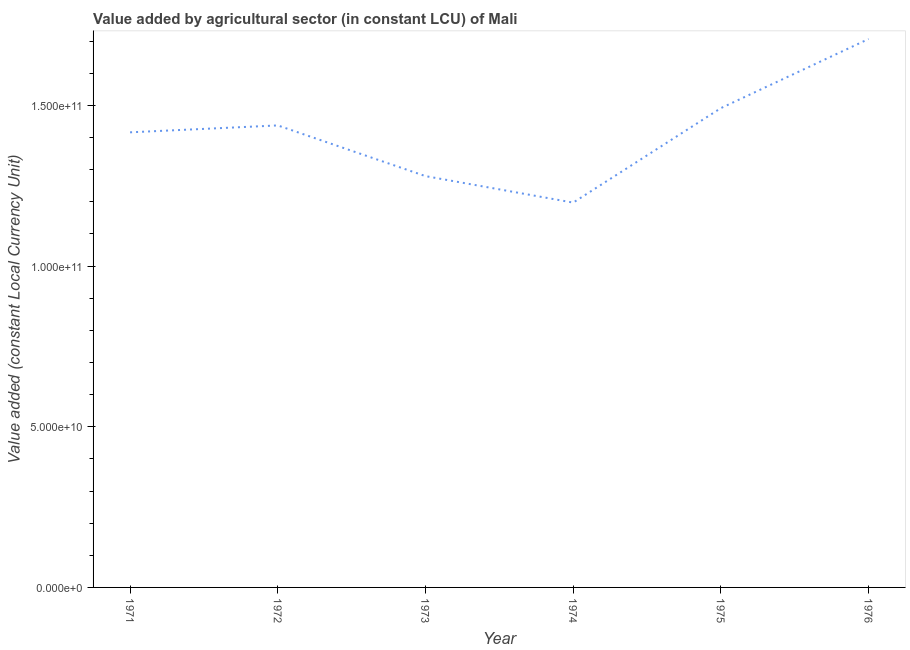What is the value added by agriculture sector in 1975?
Provide a short and direct response. 1.49e+11. Across all years, what is the maximum value added by agriculture sector?
Ensure brevity in your answer.  1.71e+11. Across all years, what is the minimum value added by agriculture sector?
Ensure brevity in your answer.  1.20e+11. In which year was the value added by agriculture sector maximum?
Ensure brevity in your answer.  1976. In which year was the value added by agriculture sector minimum?
Your answer should be compact. 1974. What is the sum of the value added by agriculture sector?
Offer a very short reply. 8.53e+11. What is the difference between the value added by agriculture sector in 1973 and 1975?
Your response must be concise. -2.12e+1. What is the average value added by agriculture sector per year?
Keep it short and to the point. 1.42e+11. What is the median value added by agriculture sector?
Your answer should be very brief. 1.43e+11. Do a majority of the years between 1971 and 1973 (inclusive) have value added by agriculture sector greater than 50000000000 LCU?
Keep it short and to the point. Yes. What is the ratio of the value added by agriculture sector in 1972 to that in 1976?
Offer a very short reply. 0.84. What is the difference between the highest and the second highest value added by agriculture sector?
Ensure brevity in your answer.  2.15e+1. Is the sum of the value added by agriculture sector in 1971 and 1972 greater than the maximum value added by agriculture sector across all years?
Your answer should be compact. Yes. What is the difference between the highest and the lowest value added by agriculture sector?
Provide a succinct answer. 5.09e+1. In how many years, is the value added by agriculture sector greater than the average value added by agriculture sector taken over all years?
Offer a very short reply. 3. Are the values on the major ticks of Y-axis written in scientific E-notation?
Keep it short and to the point. Yes. What is the title of the graph?
Your answer should be compact. Value added by agricultural sector (in constant LCU) of Mali. What is the label or title of the X-axis?
Ensure brevity in your answer.  Year. What is the label or title of the Y-axis?
Your response must be concise. Value added (constant Local Currency Unit). What is the Value added (constant Local Currency Unit) in 1971?
Keep it short and to the point. 1.42e+11. What is the Value added (constant Local Currency Unit) of 1972?
Ensure brevity in your answer.  1.44e+11. What is the Value added (constant Local Currency Unit) in 1973?
Offer a terse response. 1.28e+11. What is the Value added (constant Local Currency Unit) of 1974?
Provide a succinct answer. 1.20e+11. What is the Value added (constant Local Currency Unit) in 1975?
Offer a terse response. 1.49e+11. What is the Value added (constant Local Currency Unit) in 1976?
Offer a very short reply. 1.71e+11. What is the difference between the Value added (constant Local Currency Unit) in 1971 and 1972?
Your answer should be compact. -2.15e+09. What is the difference between the Value added (constant Local Currency Unit) in 1971 and 1973?
Keep it short and to the point. 1.36e+1. What is the difference between the Value added (constant Local Currency Unit) in 1971 and 1974?
Your response must be concise. 2.19e+1. What is the difference between the Value added (constant Local Currency Unit) in 1971 and 1975?
Provide a short and direct response. -7.53e+09. What is the difference between the Value added (constant Local Currency Unit) in 1971 and 1976?
Give a very brief answer. -2.90e+1. What is the difference between the Value added (constant Local Currency Unit) in 1972 and 1973?
Your answer should be compact. 1.58e+1. What is the difference between the Value added (constant Local Currency Unit) in 1972 and 1974?
Keep it short and to the point. 2.40e+1. What is the difference between the Value added (constant Local Currency Unit) in 1972 and 1975?
Ensure brevity in your answer.  -5.38e+09. What is the difference between the Value added (constant Local Currency Unit) in 1972 and 1976?
Provide a short and direct response. -2.69e+1. What is the difference between the Value added (constant Local Currency Unit) in 1973 and 1974?
Provide a short and direct response. 8.25e+09. What is the difference between the Value added (constant Local Currency Unit) in 1973 and 1975?
Provide a short and direct response. -2.12e+1. What is the difference between the Value added (constant Local Currency Unit) in 1973 and 1976?
Offer a very short reply. -4.27e+1. What is the difference between the Value added (constant Local Currency Unit) in 1974 and 1975?
Offer a very short reply. -2.94e+1. What is the difference between the Value added (constant Local Currency Unit) in 1974 and 1976?
Keep it short and to the point. -5.09e+1. What is the difference between the Value added (constant Local Currency Unit) in 1975 and 1976?
Ensure brevity in your answer.  -2.15e+1. What is the ratio of the Value added (constant Local Currency Unit) in 1971 to that in 1972?
Offer a terse response. 0.98. What is the ratio of the Value added (constant Local Currency Unit) in 1971 to that in 1973?
Give a very brief answer. 1.11. What is the ratio of the Value added (constant Local Currency Unit) in 1971 to that in 1974?
Offer a terse response. 1.18. What is the ratio of the Value added (constant Local Currency Unit) in 1971 to that in 1976?
Your answer should be compact. 0.83. What is the ratio of the Value added (constant Local Currency Unit) in 1972 to that in 1973?
Provide a short and direct response. 1.12. What is the ratio of the Value added (constant Local Currency Unit) in 1972 to that in 1974?
Your answer should be compact. 1.2. What is the ratio of the Value added (constant Local Currency Unit) in 1972 to that in 1975?
Your answer should be compact. 0.96. What is the ratio of the Value added (constant Local Currency Unit) in 1972 to that in 1976?
Keep it short and to the point. 0.84. What is the ratio of the Value added (constant Local Currency Unit) in 1973 to that in 1974?
Ensure brevity in your answer.  1.07. What is the ratio of the Value added (constant Local Currency Unit) in 1973 to that in 1975?
Keep it short and to the point. 0.86. What is the ratio of the Value added (constant Local Currency Unit) in 1974 to that in 1975?
Ensure brevity in your answer.  0.8. What is the ratio of the Value added (constant Local Currency Unit) in 1974 to that in 1976?
Offer a very short reply. 0.7. What is the ratio of the Value added (constant Local Currency Unit) in 1975 to that in 1976?
Give a very brief answer. 0.87. 